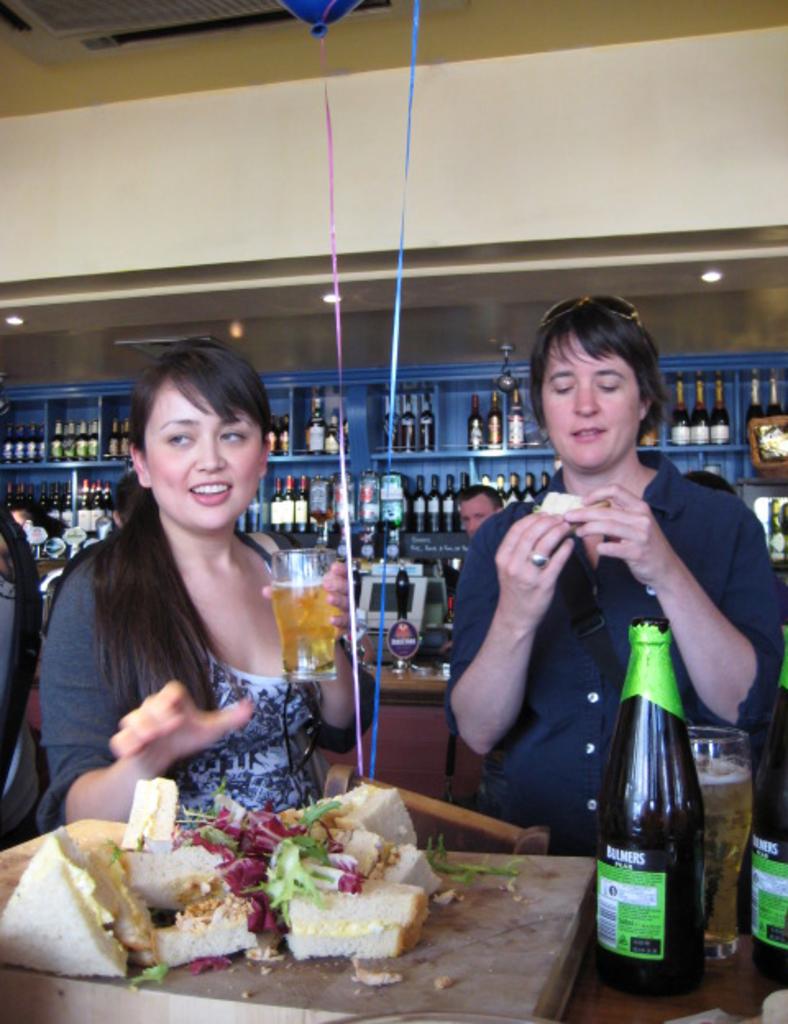What is the name of the beer?
Your answer should be compact. Bulmers. 